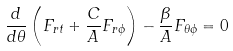<formula> <loc_0><loc_0><loc_500><loc_500>\frac { d } { d \theta } \left ( F _ { r t } + \frac { C } { A } F _ { r \phi } \right ) - \frac { \beta } { A } F _ { \theta \phi } = 0</formula> 